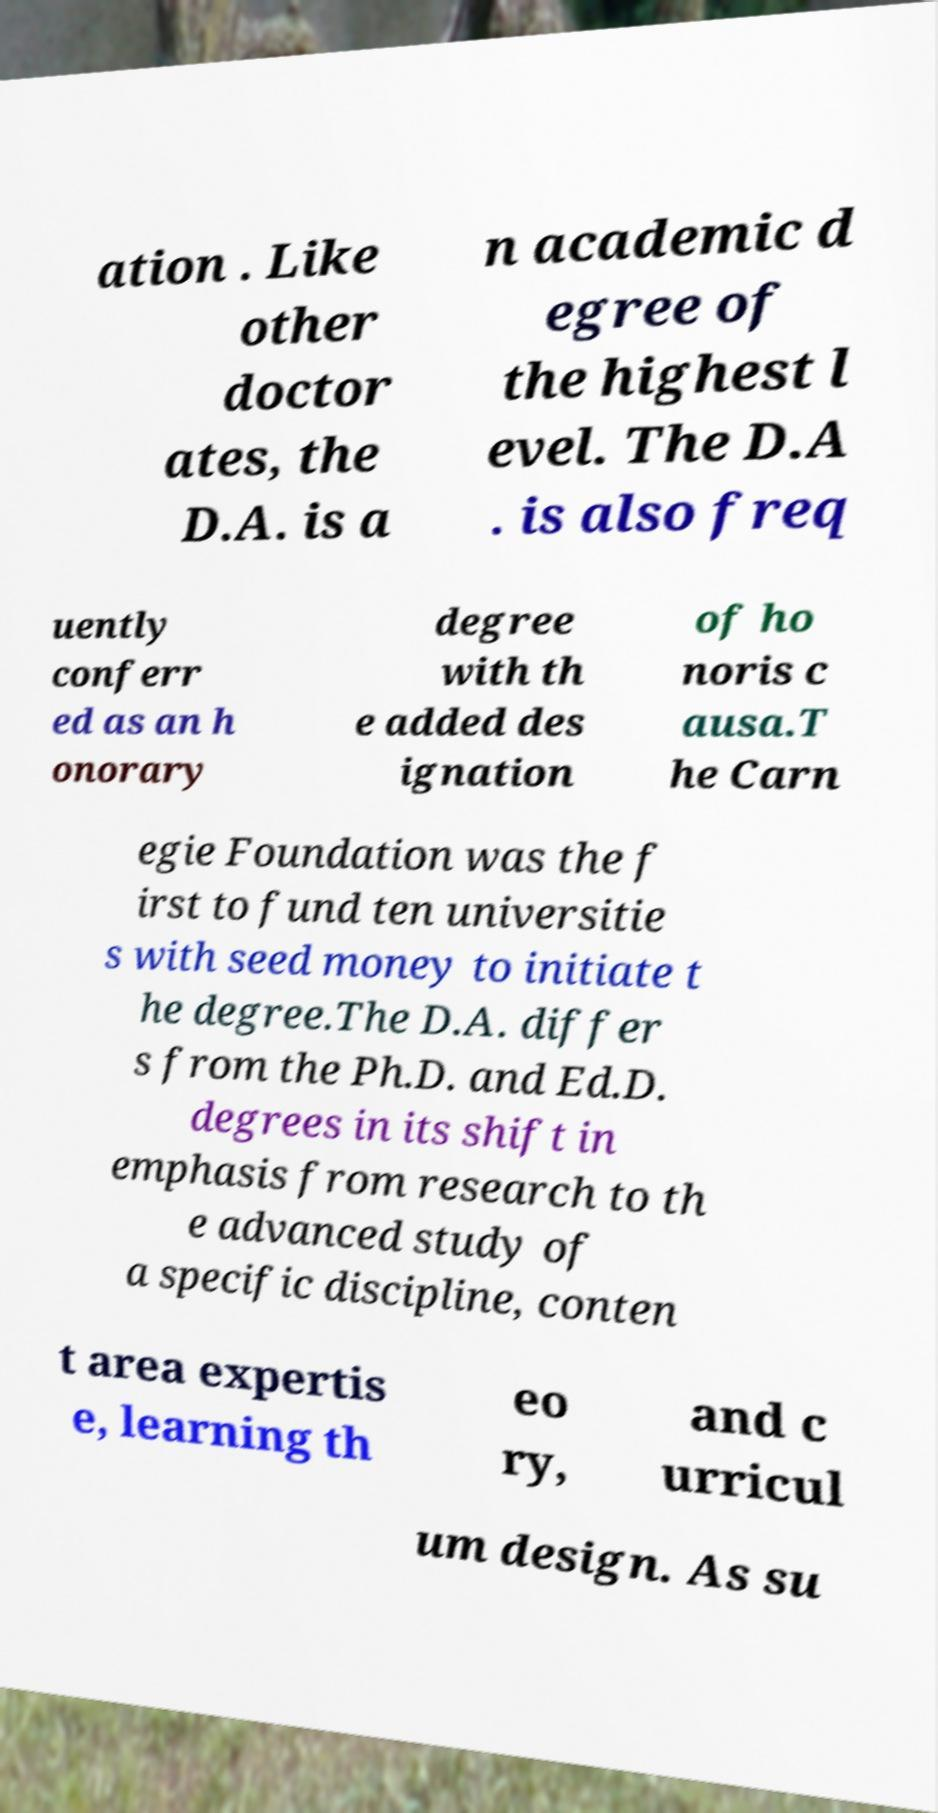Could you assist in decoding the text presented in this image and type it out clearly? ation . Like other doctor ates, the D.A. is a n academic d egree of the highest l evel. The D.A . is also freq uently conferr ed as an h onorary degree with th e added des ignation of ho noris c ausa.T he Carn egie Foundation was the f irst to fund ten universitie s with seed money to initiate t he degree.The D.A. differ s from the Ph.D. and Ed.D. degrees in its shift in emphasis from research to th e advanced study of a specific discipline, conten t area expertis e, learning th eo ry, and c urricul um design. As su 